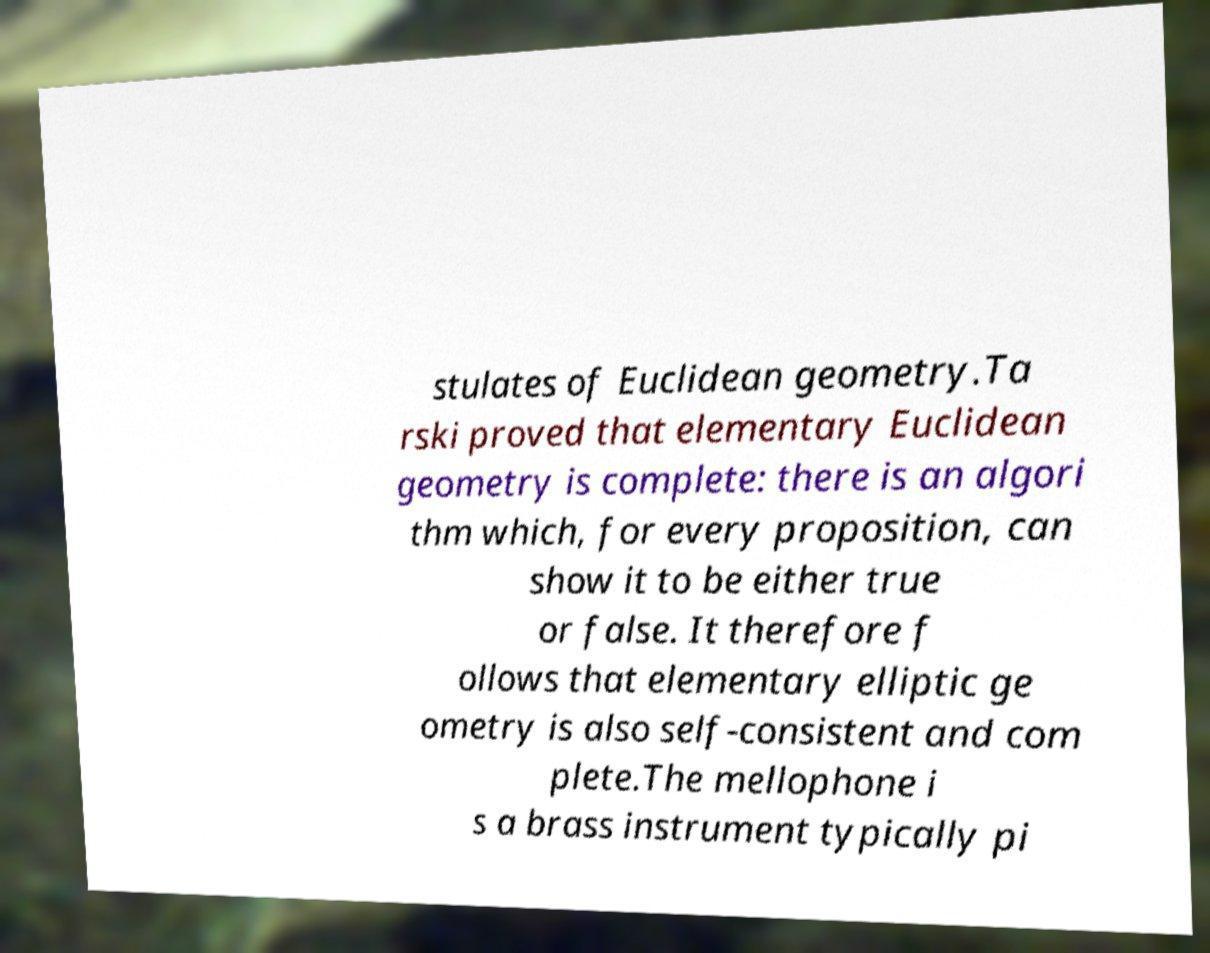Could you extract and type out the text from this image? stulates of Euclidean geometry.Ta rski proved that elementary Euclidean geometry is complete: there is an algori thm which, for every proposition, can show it to be either true or false. It therefore f ollows that elementary elliptic ge ometry is also self-consistent and com plete.The mellophone i s a brass instrument typically pi 